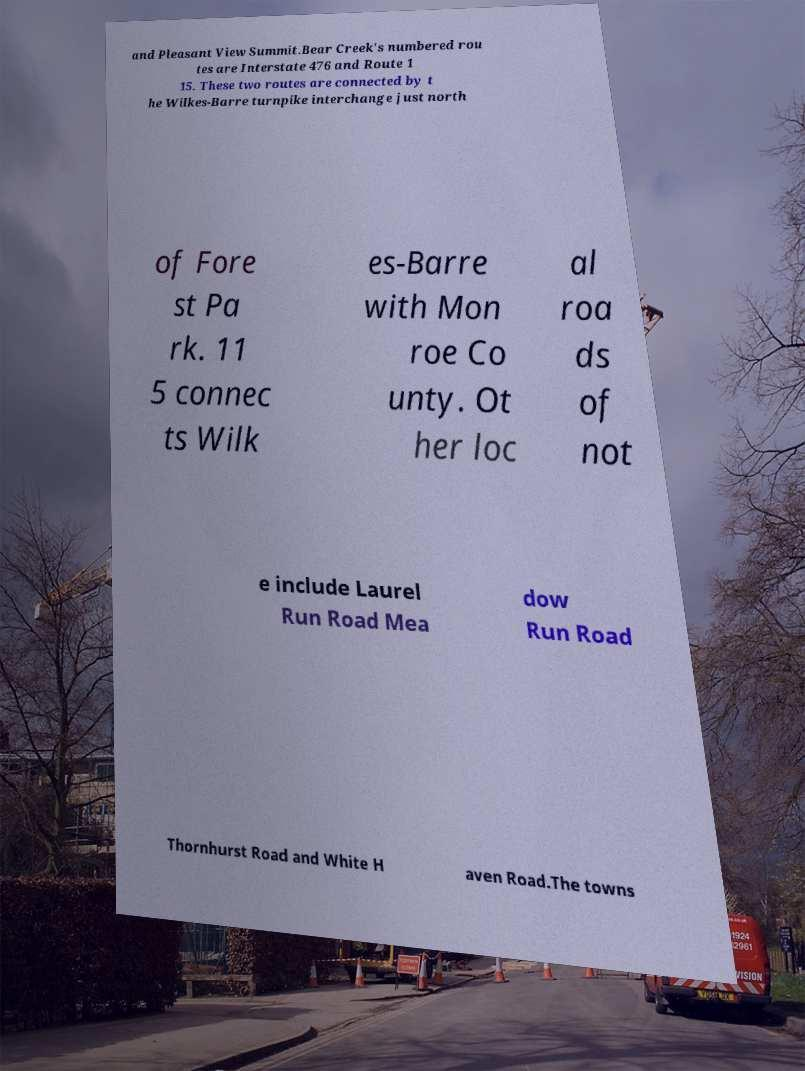For documentation purposes, I need the text within this image transcribed. Could you provide that? and Pleasant View Summit.Bear Creek's numbered rou tes are Interstate 476 and Route 1 15. These two routes are connected by t he Wilkes-Barre turnpike interchange just north of Fore st Pa rk. 11 5 connec ts Wilk es-Barre with Mon roe Co unty. Ot her loc al roa ds of not e include Laurel Run Road Mea dow Run Road Thornhurst Road and White H aven Road.The towns 